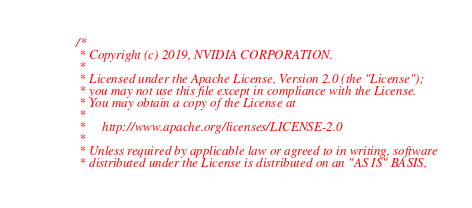<code> <loc_0><loc_0><loc_500><loc_500><_Cuda_>/*
 * Copyright (c) 2019, NVIDIA CORPORATION.
 *
 * Licensed under the Apache License, Version 2.0 (the "License");
 * you may not use this file except in compliance with the License.
 * You may obtain a copy of the License at
 *
 *     http://www.apache.org/licenses/LICENSE-2.0
 *
 * Unless required by applicable law or agreed to in writing, software
 * distributed under the License is distributed on an "AS IS" BASIS,</code> 